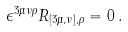Convert formula to latex. <formula><loc_0><loc_0><loc_500><loc_500>\epsilon ^ { 3 \mu \nu \rho } R _ { [ 3 \mu , \nu ] , \rho } = 0 \, .</formula> 